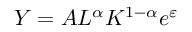<formula> <loc_0><loc_0><loc_500><loc_500>Y = A L ^ { \alpha } K ^ { 1 - \alpha } e ^ { \varepsilon }</formula> 